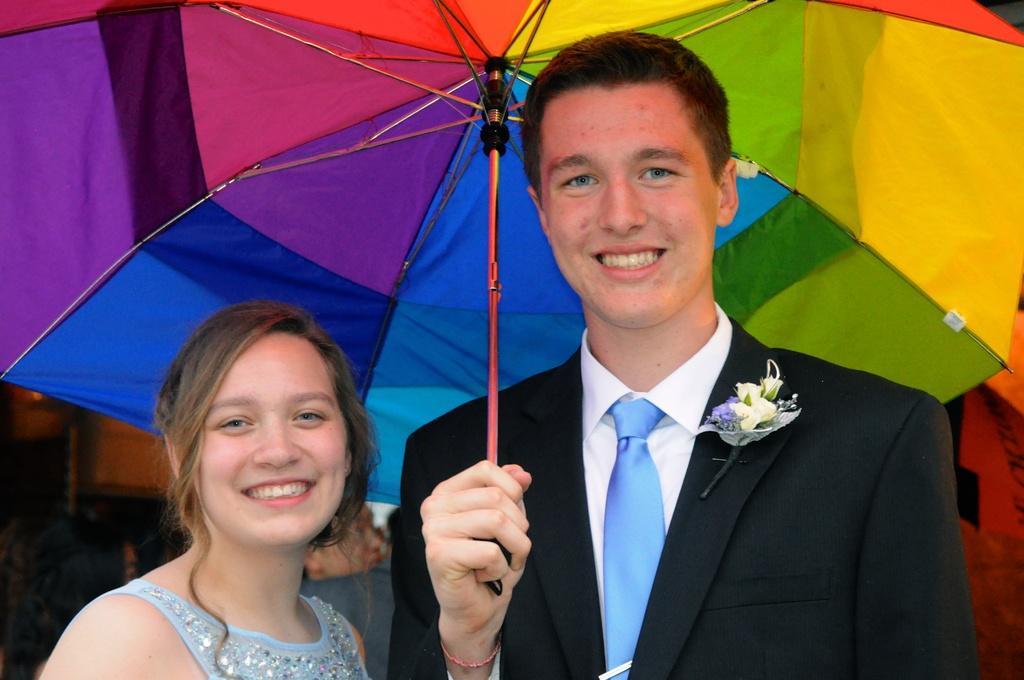Could you give a brief overview of what you see in this image? In the center of the image, we can see a man and a lady smiling and the man is holding an umbrella and wearing a coat with a flower and a tie. In the background, there are some other people. 